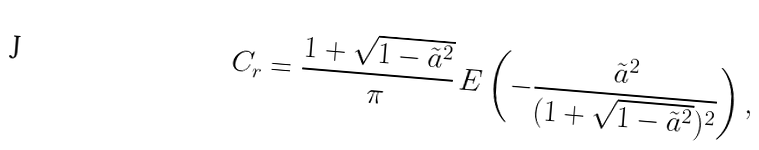<formula> <loc_0><loc_0><loc_500><loc_500>C _ { r } = \frac { 1 + \sqrt { 1 - \tilde { a } ^ { 2 } } } { \pi } \, E \left ( - \frac { \tilde { a } ^ { 2 } } { ( 1 + \sqrt { 1 - \tilde { a } ^ { 2 } } ) ^ { 2 } } \right ) ,</formula> 